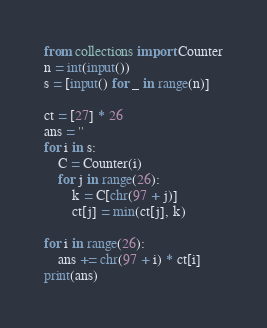<code> <loc_0><loc_0><loc_500><loc_500><_Python_>from collections import Counter
n = int(input())
s = [input() for _ in range(n)]

ct = [27] * 26
ans = ''
for i in s:
    C = Counter(i)
    for j in range(26):
        k = C[chr(97 + j)]
        ct[j] = min(ct[j], k)

for i in range(26):
    ans += chr(97 + i) * ct[i]
print(ans)</code> 